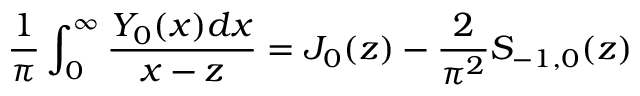<formula> <loc_0><loc_0><loc_500><loc_500>\frac { 1 } { \pi } \int _ { 0 } ^ { \infty } \frac { Y _ { 0 } ( x ) d x } { x - z } = J _ { 0 } ( z ) - \frac { 2 } { \pi ^ { 2 } } S _ { - 1 , 0 } ( z )</formula> 